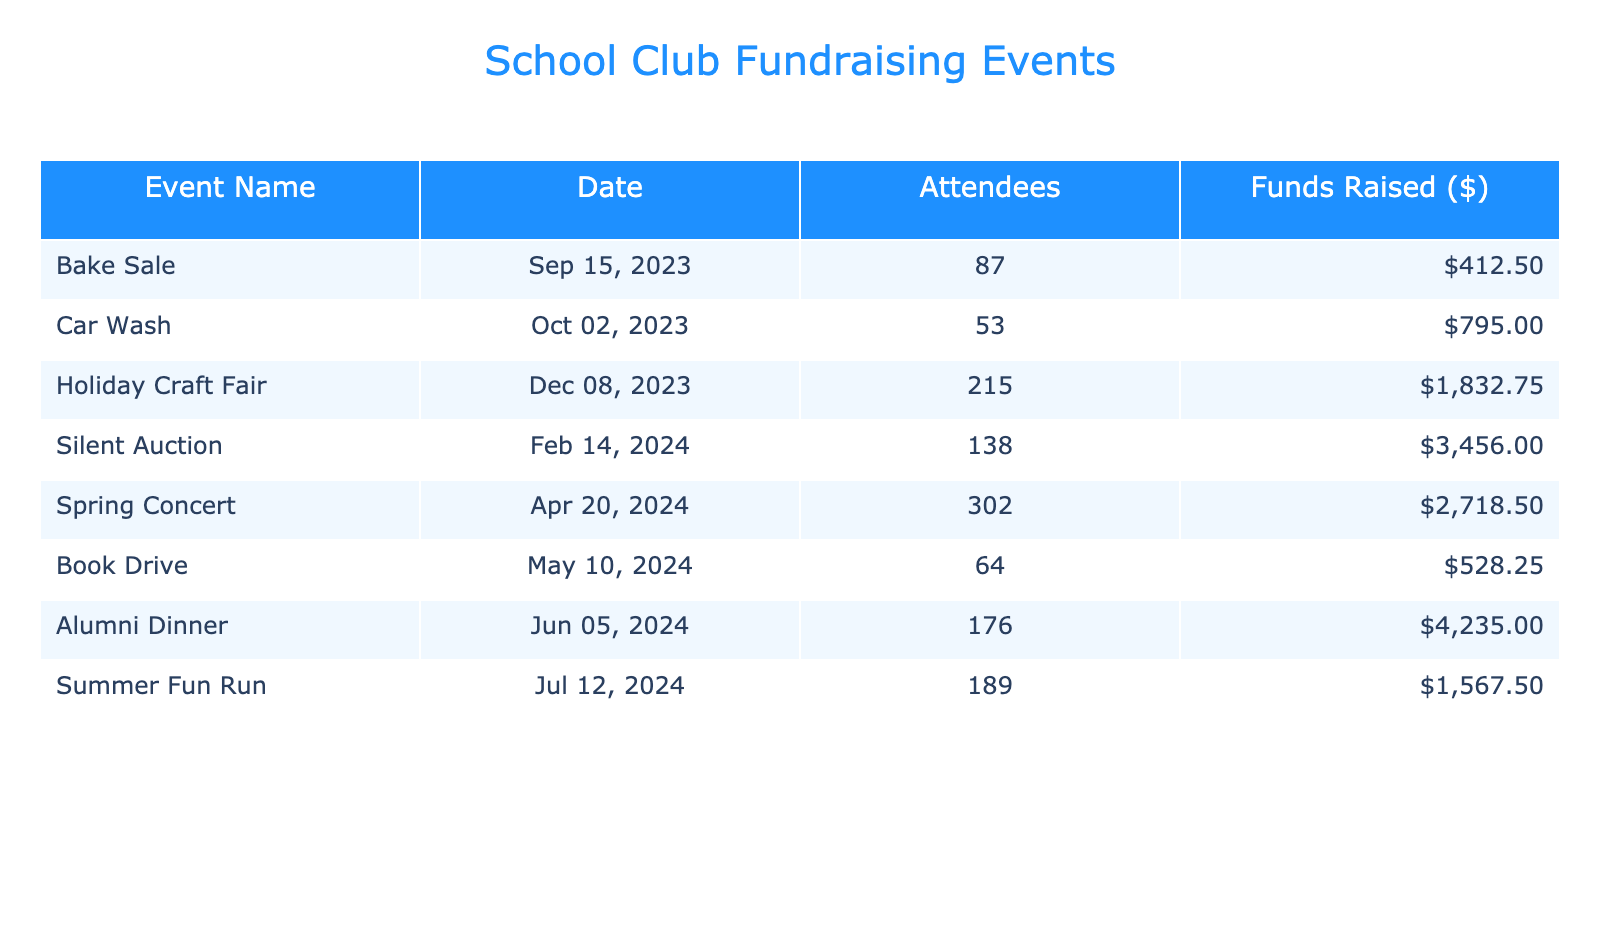What event raised the most funds? Looking at the "Funds Raised ($)" column, the Silent Auction shows the highest amount at $3,456.00.
Answer: Silent Auction How many attendees were at the Holiday Craft Fair? By checking the "Attendees" column for the Holiday Craft Fair, it shows 215 attendees.
Answer: 215 What was the total amount of funds raised across all events? To calculate the total, add the funds raised for each event: $412.50 + $795.00 + $1,832.75 + $3,456.00 + $2,718.50 + $528.25 + $4,235.00 + $1,567.50 = $15,122.50.
Answer: $15,122.50 Which event had the least number of attendees? By examining the "Attendees" column, the Book Drive has the least with 64 attendees compared to others.
Answer: Book Drive Is it true that the Alumni Dinner raised more than the Spring Concert? Comparing $4,235.00 (Alumni Dinner) and $2,718.50 (Spring Concert), the statement is true as the Alumni Dinner raised more.
Answer: Yes What is the average funds raised per event? There are 8 events. The total funds raised is $15,122.50. To find the average, divide this total by the number of events: $15,122.50 / 8 = $1,890.31.
Answer: $1,890.31 What event took place on February 14, 2024? By reviewing the "Date" column, the Silent Auction is the event scheduled for February 14, 2024.
Answer: Silent Auction How many more attendees did the Spring Concert have compared to the Car Wash? The Spring Concert had 302 attendees, and the Car Wash had 53. The difference is 302 - 53 = 249 attendees.
Answer: 249 Which two events collectively raised over $5,000? By checking the "Funds Raised ($)" for each event, the combination of the Alumni Dinner ($4,235.00) and the Silent Auction ($3,456.00) adds up to $7,691.00, which is over $5,000.
Answer: Alumni Dinner and Silent Auction What is the median amount of funds raised among the events? Arranging the funds raised from least to greatest: $412.50, $528.25, $795.00, $1,567.50, $1,832.75, $2,718.50, $3,456.00, $4,235.00, there are 8 events, so the median is the average of the 4th ($1,567.50) and 5th ($1,832.75) values: (1,567.50 + 1,832.75) / 2 = $1,700.13.
Answer: $1,700.13 